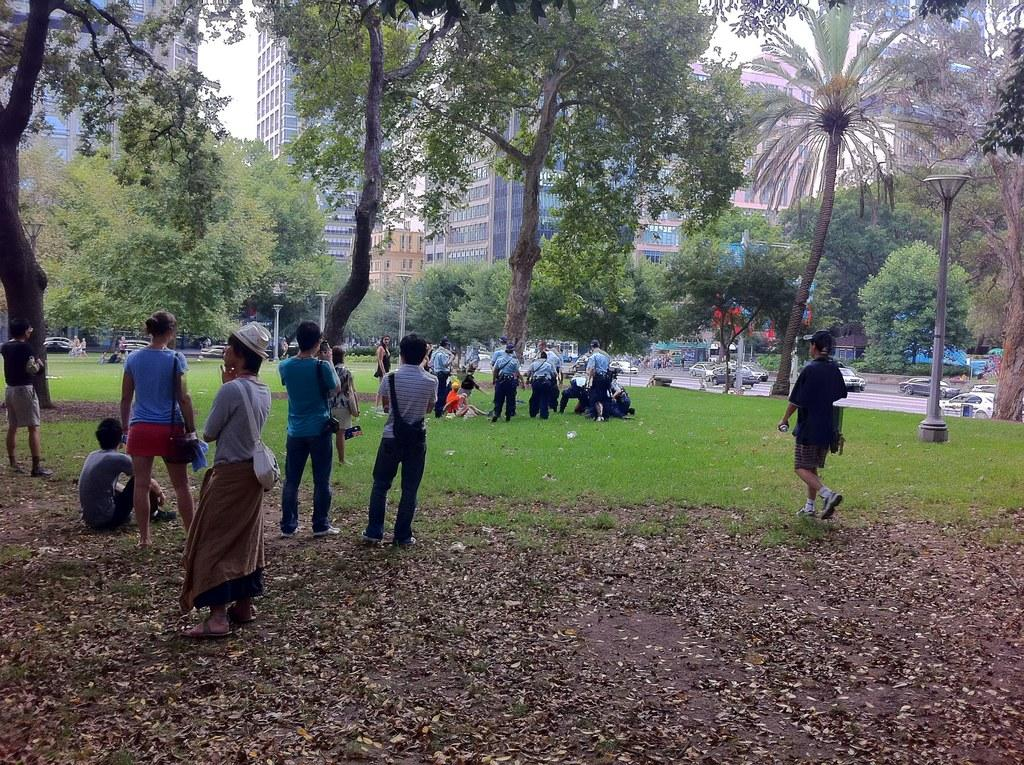What is the setting of the image? There are people standing on a grassland. What can be seen in the background of the image? There are trees, poles, buildings, and cars on a road in the background of the image. Can you describe the natural elements in the image? The natural elements in the image include grassland and trees. What type of roof can be seen on the buildings in the image? There is no roof visible in the image, as the focus is on the people and the background elements. 